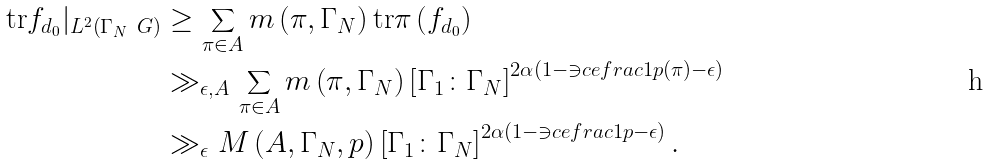<formula> <loc_0><loc_0><loc_500><loc_500>\text {tr} f _ { d _ { 0 } } | _ { L ^ { 2 } \left ( \Gamma _ { N } \ G \right ) } & \geq \sum _ { \pi \in A } m \left ( \pi , \Gamma _ { N } \right ) \text {tr} \pi \left ( f _ { d _ { 0 } } \right ) \\ & \gg _ { \epsilon , A } \sum _ { \pi \in A } m \left ( \pi , \Gamma _ { N } \right ) \left [ \Gamma _ { 1 } \colon \Gamma _ { N } \right ] ^ { 2 \alpha \left ( 1 - \ni c e f r a c { 1 } { p \left ( \pi \right ) } - \epsilon \right ) } \\ & \gg _ { \epsilon } M \left ( A , \Gamma _ { N } , p \right ) \left [ \Gamma _ { 1 } \colon \Gamma _ { N } \right ] ^ { 2 \alpha \left ( 1 - \ni c e f r a c { 1 } { p } - \epsilon \right ) } .</formula> 